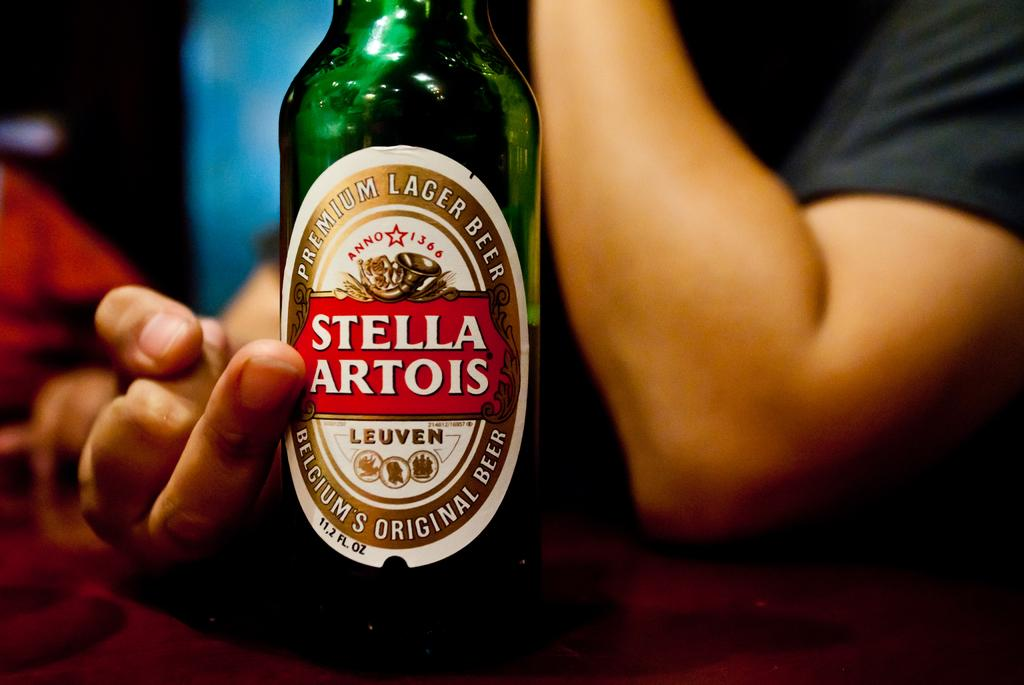What is present in the image? There is a person in the image. What is the person doing in the image? The person is touching a bottle. What type of weather can be seen in the image? There is no indication of weather in the image, as it only features a person touching a bottle. What type of system is being used by the person in the image? There is no system visible in the image; it only features a person touching a bottle. 